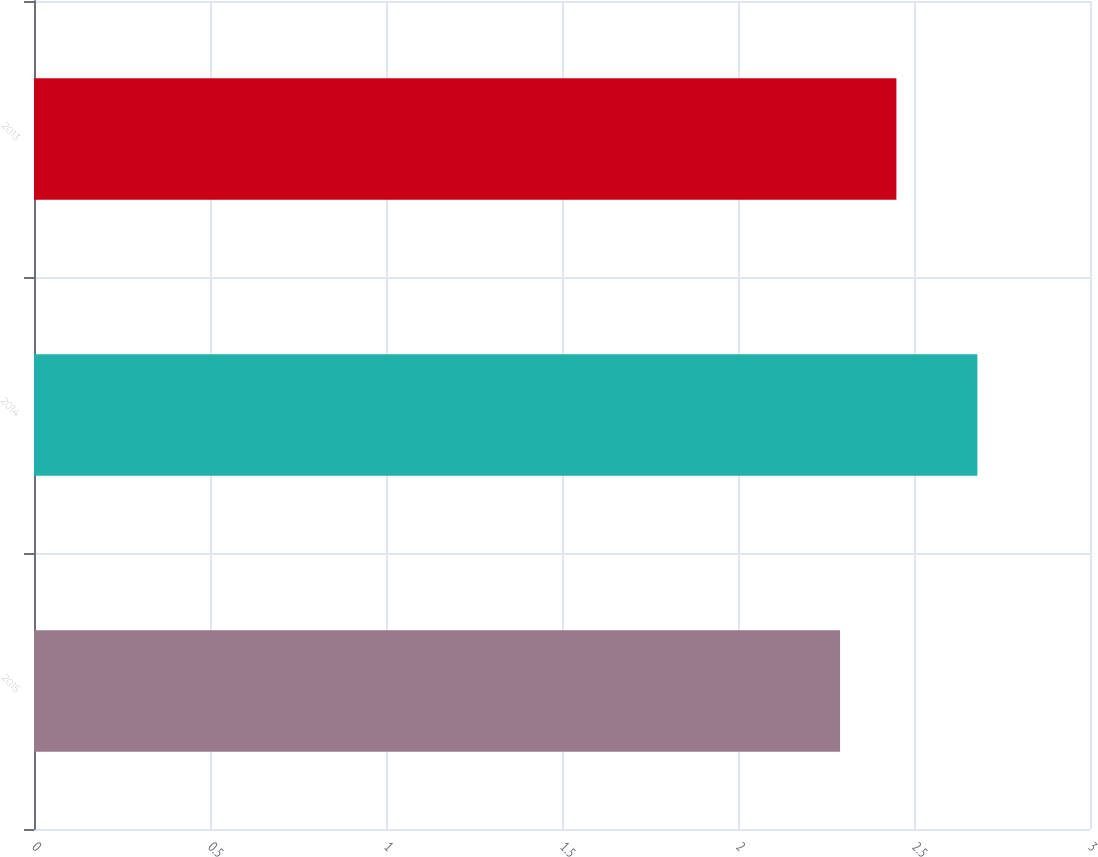<chart> <loc_0><loc_0><loc_500><loc_500><bar_chart><fcel>2015<fcel>2014<fcel>2013<nl><fcel>2.29<fcel>2.68<fcel>2.45<nl></chart> 